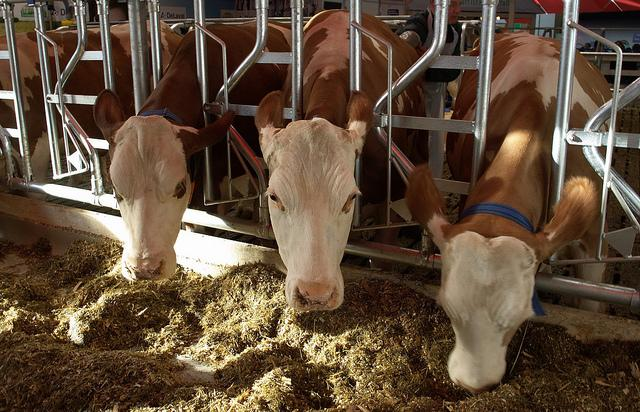Why are the animals putting their face to the ground? eating 